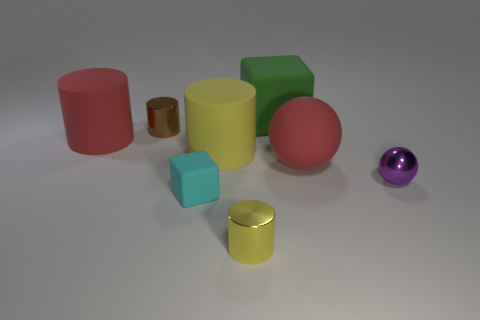What are the shapes of the objects in the image? The image contains a variety of shapes including cylinders, a cube, and spheres. Can you tell me which object stands out the most? The large red cylinder stands out because of its vibrant color and size relative to the other objects. 